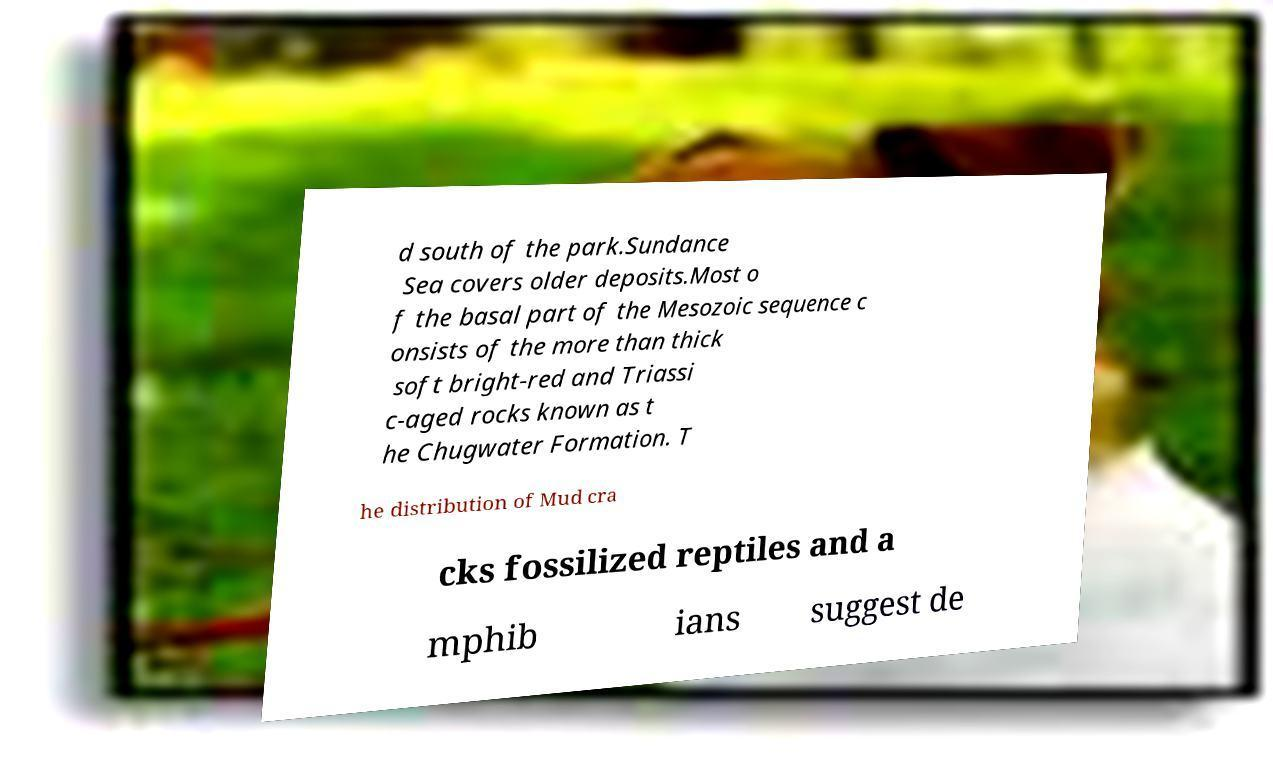Could you extract and type out the text from this image? d south of the park.Sundance Sea covers older deposits.Most o f the basal part of the Mesozoic sequence c onsists of the more than thick soft bright-red and Triassi c-aged rocks known as t he Chugwater Formation. T he distribution of Mud cra cks fossilized reptiles and a mphib ians suggest de 